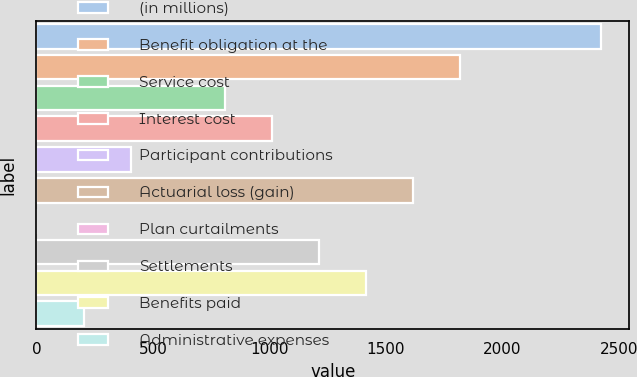<chart> <loc_0><loc_0><loc_500><loc_500><bar_chart><fcel>(in millions)<fcel>Benefit obligation at the<fcel>Service cost<fcel>Interest cost<fcel>Participant contributions<fcel>Actuarial loss (gain)<fcel>Plan curtailments<fcel>Settlements<fcel>Benefits paid<fcel>Administrative expenses<nl><fcel>2422.78<fcel>1817.11<fcel>807.66<fcel>1009.55<fcel>403.88<fcel>1615.22<fcel>0.1<fcel>1211.44<fcel>1413.33<fcel>201.99<nl></chart> 